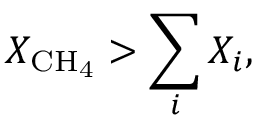<formula> <loc_0><loc_0><loc_500><loc_500>X _ { C H _ { 4 } } > \sum _ { i } X _ { i } ,</formula> 